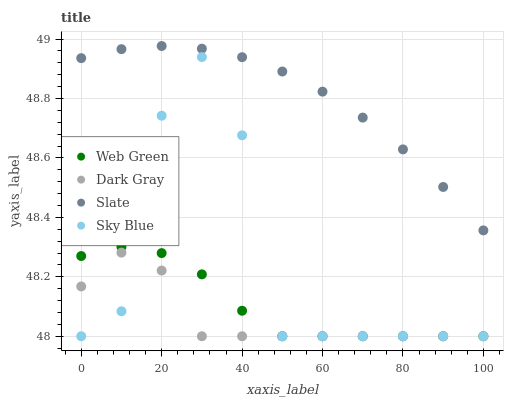Does Dark Gray have the minimum area under the curve?
Answer yes or no. Yes. Does Slate have the maximum area under the curve?
Answer yes or no. Yes. Does Sky Blue have the minimum area under the curve?
Answer yes or no. No. Does Sky Blue have the maximum area under the curve?
Answer yes or no. No. Is Slate the smoothest?
Answer yes or no. Yes. Is Sky Blue the roughest?
Answer yes or no. Yes. Is Sky Blue the smoothest?
Answer yes or no. No. Is Slate the roughest?
Answer yes or no. No. Does Dark Gray have the lowest value?
Answer yes or no. Yes. Does Slate have the lowest value?
Answer yes or no. No. Does Slate have the highest value?
Answer yes or no. Yes. Does Sky Blue have the highest value?
Answer yes or no. No. Is Sky Blue less than Slate?
Answer yes or no. Yes. Is Slate greater than Sky Blue?
Answer yes or no. Yes. Does Sky Blue intersect Web Green?
Answer yes or no. Yes. Is Sky Blue less than Web Green?
Answer yes or no. No. Is Sky Blue greater than Web Green?
Answer yes or no. No. Does Sky Blue intersect Slate?
Answer yes or no. No. 